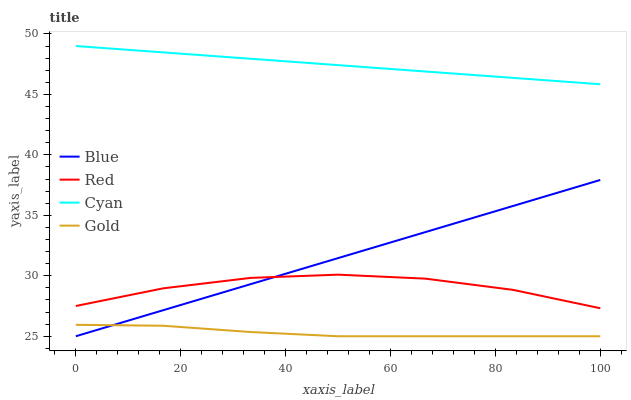Does Gold have the minimum area under the curve?
Answer yes or no. Yes. Does Cyan have the maximum area under the curve?
Answer yes or no. Yes. Does Cyan have the minimum area under the curve?
Answer yes or no. No. Does Gold have the maximum area under the curve?
Answer yes or no. No. Is Cyan the smoothest?
Answer yes or no. Yes. Is Red the roughest?
Answer yes or no. Yes. Is Gold the smoothest?
Answer yes or no. No. Is Gold the roughest?
Answer yes or no. No. Does Blue have the lowest value?
Answer yes or no. Yes. Does Cyan have the lowest value?
Answer yes or no. No. Does Cyan have the highest value?
Answer yes or no. Yes. Does Gold have the highest value?
Answer yes or no. No. Is Red less than Cyan?
Answer yes or no. Yes. Is Red greater than Gold?
Answer yes or no. Yes. Does Gold intersect Blue?
Answer yes or no. Yes. Is Gold less than Blue?
Answer yes or no. No. Is Gold greater than Blue?
Answer yes or no. No. Does Red intersect Cyan?
Answer yes or no. No. 